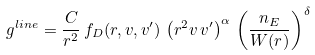Convert formula to latex. <formula><loc_0><loc_0><loc_500><loc_500>g ^ { l i n e } = \frac { C } { r ^ { 2 } } \, f _ { D } ( r , v , v ^ { \prime } ) \, \left ( r ^ { 2 } v \, v ^ { \prime } \right ) ^ { \alpha } \, \left ( \frac { n _ { E } } { W ( r ) } \right ) ^ { \delta }</formula> 